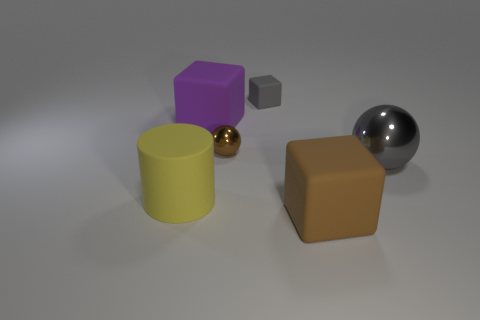What is the shape of the big thing that is the same color as the small shiny ball?
Give a very brief answer. Cube. Is the big cube that is behind the large brown block made of the same material as the big yellow cylinder?
Provide a succinct answer. Yes. What number of objects are both in front of the tiny sphere and to the right of the large yellow object?
Your response must be concise. 2. What number of big purple blocks have the same material as the cylinder?
Make the answer very short. 1. There is a tiny block that is made of the same material as the purple object; what color is it?
Your response must be concise. Gray. Are there fewer tiny brown rubber cylinders than small gray blocks?
Your answer should be compact. Yes. What material is the block in front of the big cube on the left side of the gray thing that is left of the gray sphere made of?
Give a very brief answer. Rubber. What is the purple thing made of?
Offer a terse response. Rubber. Do the metallic sphere right of the large brown matte thing and the large block that is in front of the gray metallic sphere have the same color?
Offer a terse response. No. Is the number of big matte blocks greater than the number of large brown rubber things?
Give a very brief answer. Yes. 